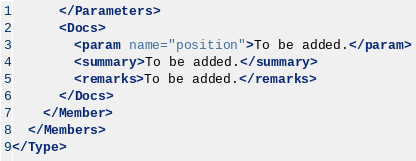Convert code to text. <code><loc_0><loc_0><loc_500><loc_500><_XML_>      </Parameters>
      <Docs>
        <param name="position">To be added.</param>
        <summary>To be added.</summary>
        <remarks>To be added.</remarks>
      </Docs>
    </Member>
  </Members>
</Type>
</code> 